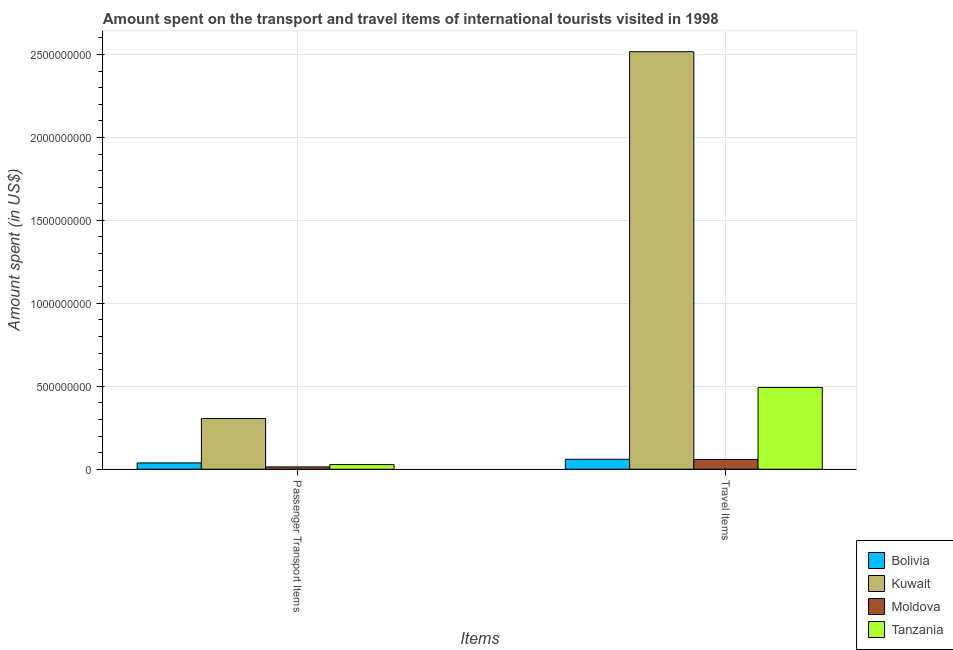How many groups of bars are there?
Provide a succinct answer. 2. Are the number of bars per tick equal to the number of legend labels?
Provide a succinct answer. Yes. How many bars are there on the 2nd tick from the left?
Give a very brief answer. 4. What is the label of the 1st group of bars from the left?
Provide a succinct answer. Passenger Transport Items. What is the amount spent on passenger transport items in Moldova?
Your response must be concise. 1.40e+07. Across all countries, what is the maximum amount spent in travel items?
Make the answer very short. 2.52e+09. Across all countries, what is the minimum amount spent on passenger transport items?
Your answer should be very brief. 1.40e+07. In which country was the amount spent on passenger transport items maximum?
Keep it short and to the point. Kuwait. In which country was the amount spent on passenger transport items minimum?
Your answer should be compact. Moldova. What is the total amount spent in travel items in the graph?
Provide a succinct answer. 3.13e+09. What is the difference between the amount spent in travel items in Kuwait and that in Bolivia?
Offer a very short reply. 2.46e+09. What is the difference between the amount spent on passenger transport items in Moldova and the amount spent in travel items in Bolivia?
Make the answer very short. -4.60e+07. What is the average amount spent in travel items per country?
Ensure brevity in your answer.  7.82e+08. What is the difference between the amount spent on passenger transport items and amount spent in travel items in Bolivia?
Your answer should be very brief. -2.20e+07. In how many countries, is the amount spent in travel items greater than 1700000000 US$?
Keep it short and to the point. 1. What is the ratio of the amount spent on passenger transport items in Kuwait to that in Moldova?
Offer a terse response. 21.86. What does the 1st bar from the left in Travel Items represents?
Make the answer very short. Bolivia. What does the 2nd bar from the right in Passenger Transport Items represents?
Offer a very short reply. Moldova. How many bars are there?
Make the answer very short. 8. Are all the bars in the graph horizontal?
Your answer should be compact. No. How many countries are there in the graph?
Your answer should be compact. 4. What is the difference between two consecutive major ticks on the Y-axis?
Your answer should be compact. 5.00e+08. Does the graph contain any zero values?
Offer a very short reply. No. How many legend labels are there?
Your answer should be compact. 4. How are the legend labels stacked?
Ensure brevity in your answer.  Vertical. What is the title of the graph?
Provide a succinct answer. Amount spent on the transport and travel items of international tourists visited in 1998. What is the label or title of the X-axis?
Offer a terse response. Items. What is the label or title of the Y-axis?
Your answer should be compact. Amount spent (in US$). What is the Amount spent (in US$) in Bolivia in Passenger Transport Items?
Keep it short and to the point. 3.80e+07. What is the Amount spent (in US$) of Kuwait in Passenger Transport Items?
Ensure brevity in your answer.  3.06e+08. What is the Amount spent (in US$) in Moldova in Passenger Transport Items?
Provide a short and direct response. 1.40e+07. What is the Amount spent (in US$) in Tanzania in Passenger Transport Items?
Give a very brief answer. 2.80e+07. What is the Amount spent (in US$) in Bolivia in Travel Items?
Offer a very short reply. 6.00e+07. What is the Amount spent (in US$) of Kuwait in Travel Items?
Keep it short and to the point. 2.52e+09. What is the Amount spent (in US$) of Moldova in Travel Items?
Provide a succinct answer. 5.90e+07. What is the Amount spent (in US$) of Tanzania in Travel Items?
Offer a terse response. 4.93e+08. Across all Items, what is the maximum Amount spent (in US$) of Bolivia?
Keep it short and to the point. 6.00e+07. Across all Items, what is the maximum Amount spent (in US$) of Kuwait?
Provide a succinct answer. 2.52e+09. Across all Items, what is the maximum Amount spent (in US$) in Moldova?
Make the answer very short. 5.90e+07. Across all Items, what is the maximum Amount spent (in US$) of Tanzania?
Offer a terse response. 4.93e+08. Across all Items, what is the minimum Amount spent (in US$) of Bolivia?
Your answer should be compact. 3.80e+07. Across all Items, what is the minimum Amount spent (in US$) of Kuwait?
Ensure brevity in your answer.  3.06e+08. Across all Items, what is the minimum Amount spent (in US$) of Moldova?
Offer a terse response. 1.40e+07. Across all Items, what is the minimum Amount spent (in US$) of Tanzania?
Provide a succinct answer. 2.80e+07. What is the total Amount spent (in US$) in Bolivia in the graph?
Your response must be concise. 9.80e+07. What is the total Amount spent (in US$) of Kuwait in the graph?
Make the answer very short. 2.82e+09. What is the total Amount spent (in US$) in Moldova in the graph?
Provide a succinct answer. 7.30e+07. What is the total Amount spent (in US$) of Tanzania in the graph?
Provide a short and direct response. 5.21e+08. What is the difference between the Amount spent (in US$) of Bolivia in Passenger Transport Items and that in Travel Items?
Ensure brevity in your answer.  -2.20e+07. What is the difference between the Amount spent (in US$) of Kuwait in Passenger Transport Items and that in Travel Items?
Give a very brief answer. -2.21e+09. What is the difference between the Amount spent (in US$) of Moldova in Passenger Transport Items and that in Travel Items?
Offer a terse response. -4.50e+07. What is the difference between the Amount spent (in US$) in Tanzania in Passenger Transport Items and that in Travel Items?
Offer a terse response. -4.65e+08. What is the difference between the Amount spent (in US$) in Bolivia in Passenger Transport Items and the Amount spent (in US$) in Kuwait in Travel Items?
Provide a succinct answer. -2.48e+09. What is the difference between the Amount spent (in US$) of Bolivia in Passenger Transport Items and the Amount spent (in US$) of Moldova in Travel Items?
Provide a succinct answer. -2.10e+07. What is the difference between the Amount spent (in US$) of Bolivia in Passenger Transport Items and the Amount spent (in US$) of Tanzania in Travel Items?
Keep it short and to the point. -4.55e+08. What is the difference between the Amount spent (in US$) of Kuwait in Passenger Transport Items and the Amount spent (in US$) of Moldova in Travel Items?
Offer a very short reply. 2.47e+08. What is the difference between the Amount spent (in US$) in Kuwait in Passenger Transport Items and the Amount spent (in US$) in Tanzania in Travel Items?
Provide a succinct answer. -1.87e+08. What is the difference between the Amount spent (in US$) of Moldova in Passenger Transport Items and the Amount spent (in US$) of Tanzania in Travel Items?
Your answer should be very brief. -4.79e+08. What is the average Amount spent (in US$) of Bolivia per Items?
Give a very brief answer. 4.90e+07. What is the average Amount spent (in US$) in Kuwait per Items?
Offer a very short reply. 1.41e+09. What is the average Amount spent (in US$) in Moldova per Items?
Keep it short and to the point. 3.65e+07. What is the average Amount spent (in US$) in Tanzania per Items?
Ensure brevity in your answer.  2.60e+08. What is the difference between the Amount spent (in US$) in Bolivia and Amount spent (in US$) in Kuwait in Passenger Transport Items?
Provide a succinct answer. -2.68e+08. What is the difference between the Amount spent (in US$) of Bolivia and Amount spent (in US$) of Moldova in Passenger Transport Items?
Your answer should be compact. 2.40e+07. What is the difference between the Amount spent (in US$) of Kuwait and Amount spent (in US$) of Moldova in Passenger Transport Items?
Your response must be concise. 2.92e+08. What is the difference between the Amount spent (in US$) in Kuwait and Amount spent (in US$) in Tanzania in Passenger Transport Items?
Provide a short and direct response. 2.78e+08. What is the difference between the Amount spent (in US$) in Moldova and Amount spent (in US$) in Tanzania in Passenger Transport Items?
Ensure brevity in your answer.  -1.40e+07. What is the difference between the Amount spent (in US$) of Bolivia and Amount spent (in US$) of Kuwait in Travel Items?
Make the answer very short. -2.46e+09. What is the difference between the Amount spent (in US$) of Bolivia and Amount spent (in US$) of Moldova in Travel Items?
Make the answer very short. 1.00e+06. What is the difference between the Amount spent (in US$) of Bolivia and Amount spent (in US$) of Tanzania in Travel Items?
Ensure brevity in your answer.  -4.33e+08. What is the difference between the Amount spent (in US$) of Kuwait and Amount spent (in US$) of Moldova in Travel Items?
Provide a short and direct response. 2.46e+09. What is the difference between the Amount spent (in US$) of Kuwait and Amount spent (in US$) of Tanzania in Travel Items?
Your answer should be compact. 2.02e+09. What is the difference between the Amount spent (in US$) in Moldova and Amount spent (in US$) in Tanzania in Travel Items?
Your answer should be very brief. -4.34e+08. What is the ratio of the Amount spent (in US$) of Bolivia in Passenger Transport Items to that in Travel Items?
Make the answer very short. 0.63. What is the ratio of the Amount spent (in US$) of Kuwait in Passenger Transport Items to that in Travel Items?
Your answer should be very brief. 0.12. What is the ratio of the Amount spent (in US$) of Moldova in Passenger Transport Items to that in Travel Items?
Your response must be concise. 0.24. What is the ratio of the Amount spent (in US$) of Tanzania in Passenger Transport Items to that in Travel Items?
Keep it short and to the point. 0.06. What is the difference between the highest and the second highest Amount spent (in US$) in Bolivia?
Keep it short and to the point. 2.20e+07. What is the difference between the highest and the second highest Amount spent (in US$) in Kuwait?
Provide a succinct answer. 2.21e+09. What is the difference between the highest and the second highest Amount spent (in US$) of Moldova?
Keep it short and to the point. 4.50e+07. What is the difference between the highest and the second highest Amount spent (in US$) in Tanzania?
Offer a terse response. 4.65e+08. What is the difference between the highest and the lowest Amount spent (in US$) of Bolivia?
Offer a very short reply. 2.20e+07. What is the difference between the highest and the lowest Amount spent (in US$) of Kuwait?
Your response must be concise. 2.21e+09. What is the difference between the highest and the lowest Amount spent (in US$) of Moldova?
Make the answer very short. 4.50e+07. What is the difference between the highest and the lowest Amount spent (in US$) of Tanzania?
Provide a succinct answer. 4.65e+08. 